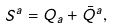<formula> <loc_0><loc_0><loc_500><loc_500>S ^ { a } = Q _ { a } + \bar { Q } ^ { a } ,</formula> 